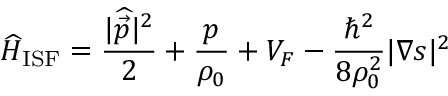Convert formula to latex. <formula><loc_0><loc_0><loc_500><loc_500>\widehat { H } _ { I S F } = \frac { | \widehat { \vec { p } } | ^ { 2 } } { 2 } + \frac { p } { \rho _ { 0 } } + V _ { F } - \frac { \hbar { ^ } { 2 } } { 8 \rho _ { 0 } ^ { 2 } } | \nabla s | ^ { 2 }</formula> 